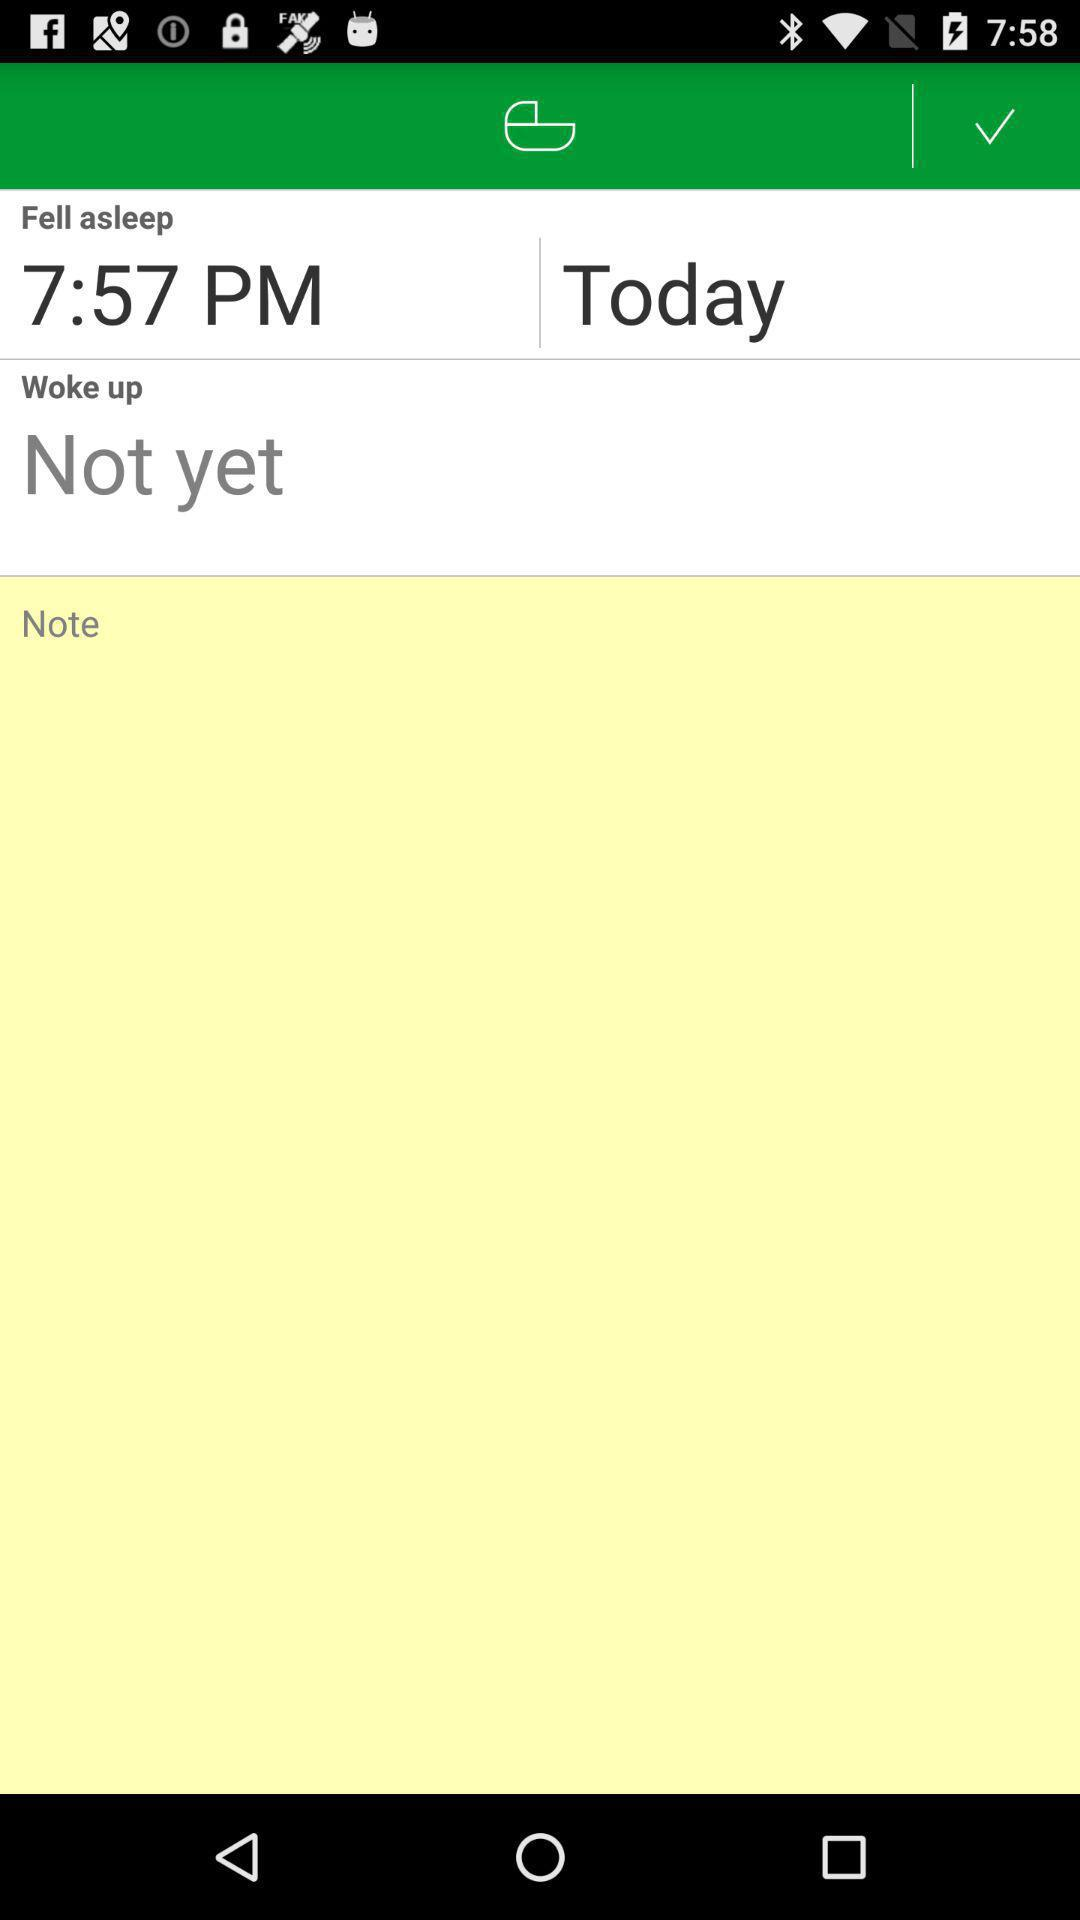What is the snooze time for today? The snooze time for today is 7:57 PM. 